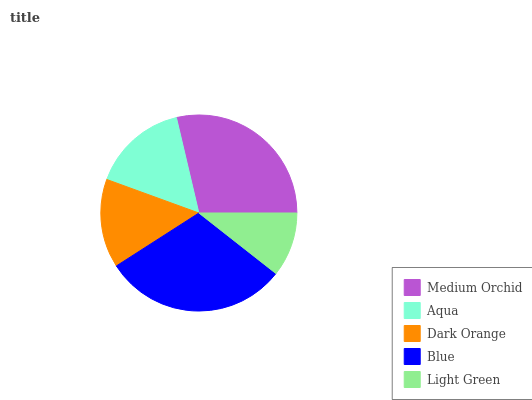Is Light Green the minimum?
Answer yes or no. Yes. Is Blue the maximum?
Answer yes or no. Yes. Is Aqua the minimum?
Answer yes or no. No. Is Aqua the maximum?
Answer yes or no. No. Is Medium Orchid greater than Aqua?
Answer yes or no. Yes. Is Aqua less than Medium Orchid?
Answer yes or no. Yes. Is Aqua greater than Medium Orchid?
Answer yes or no. No. Is Medium Orchid less than Aqua?
Answer yes or no. No. Is Aqua the high median?
Answer yes or no. Yes. Is Aqua the low median?
Answer yes or no. Yes. Is Blue the high median?
Answer yes or no. No. Is Dark Orange the low median?
Answer yes or no. No. 